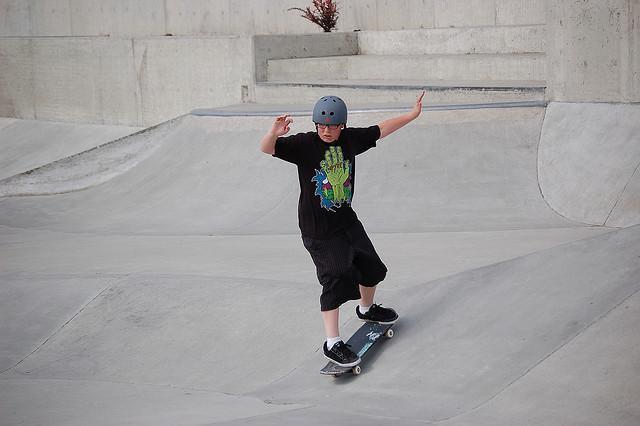How many steps are there?
Give a very brief answer. 3. How many horses are in the photo?
Give a very brief answer. 0. 